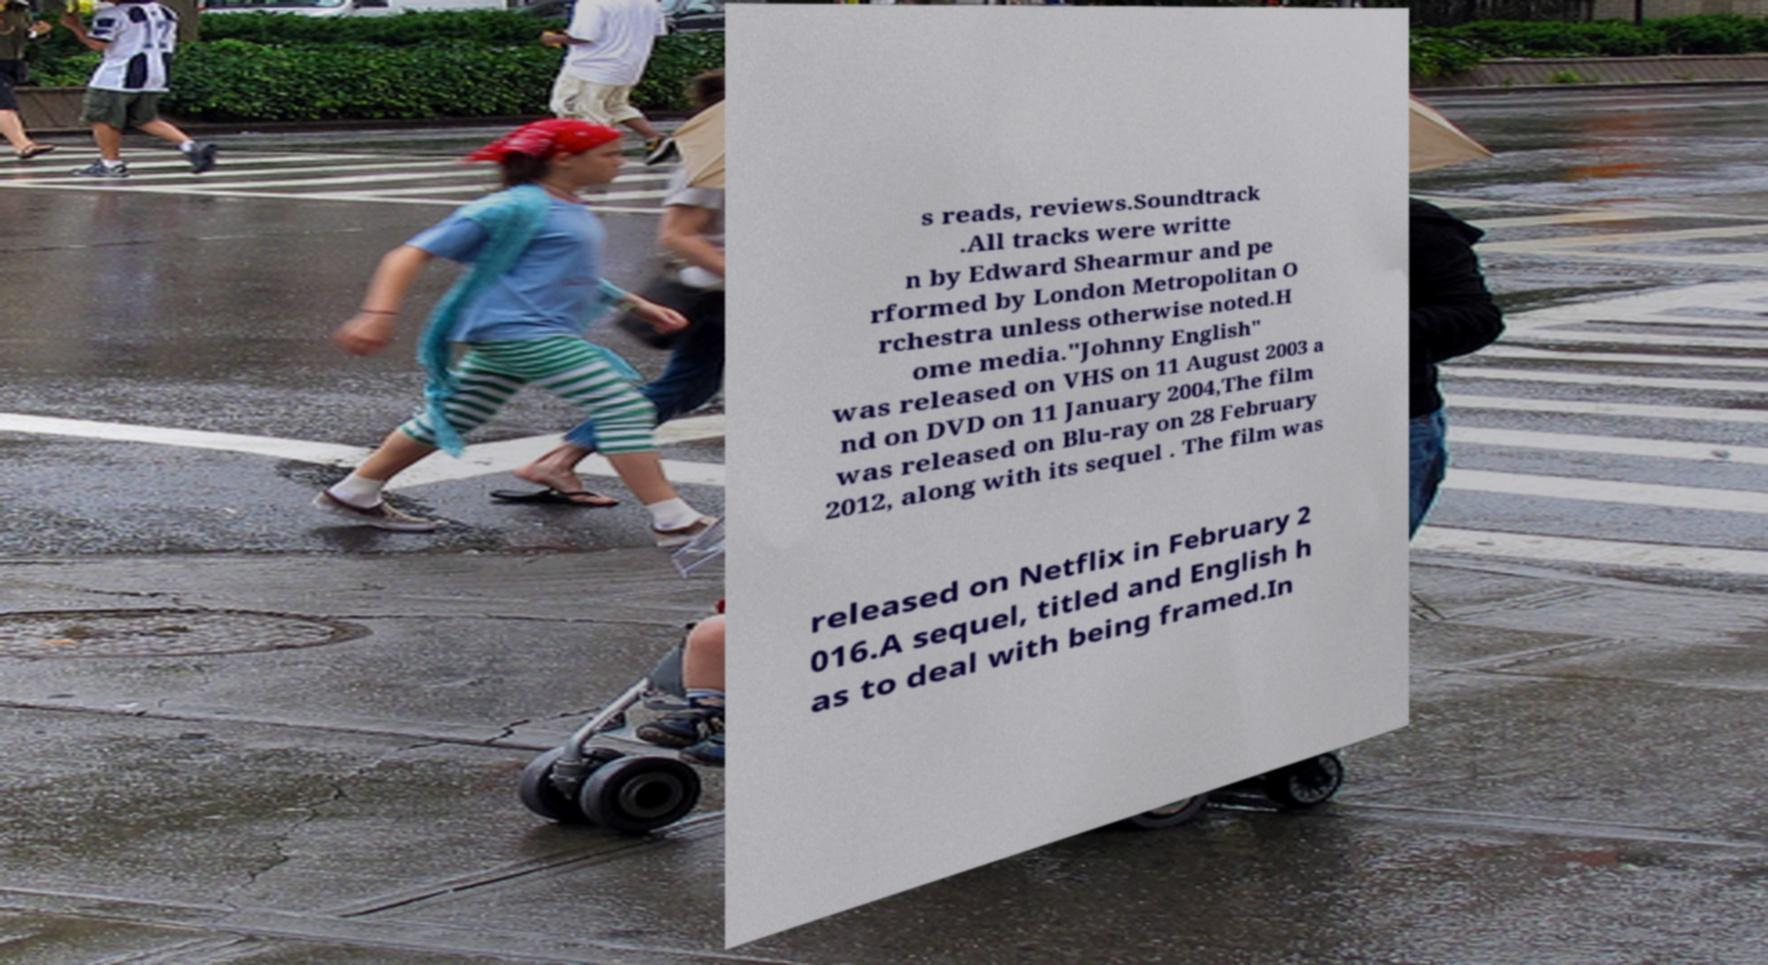There's text embedded in this image that I need extracted. Can you transcribe it verbatim? s reads, reviews.Soundtrack .All tracks were writte n by Edward Shearmur and pe rformed by London Metropolitan O rchestra unless otherwise noted.H ome media."Johnny English" was released on VHS on 11 August 2003 a nd on DVD on 11 January 2004,The film was released on Blu-ray on 28 February 2012, along with its sequel . The film was released on Netflix in February 2 016.A sequel, titled and English h as to deal with being framed.In 